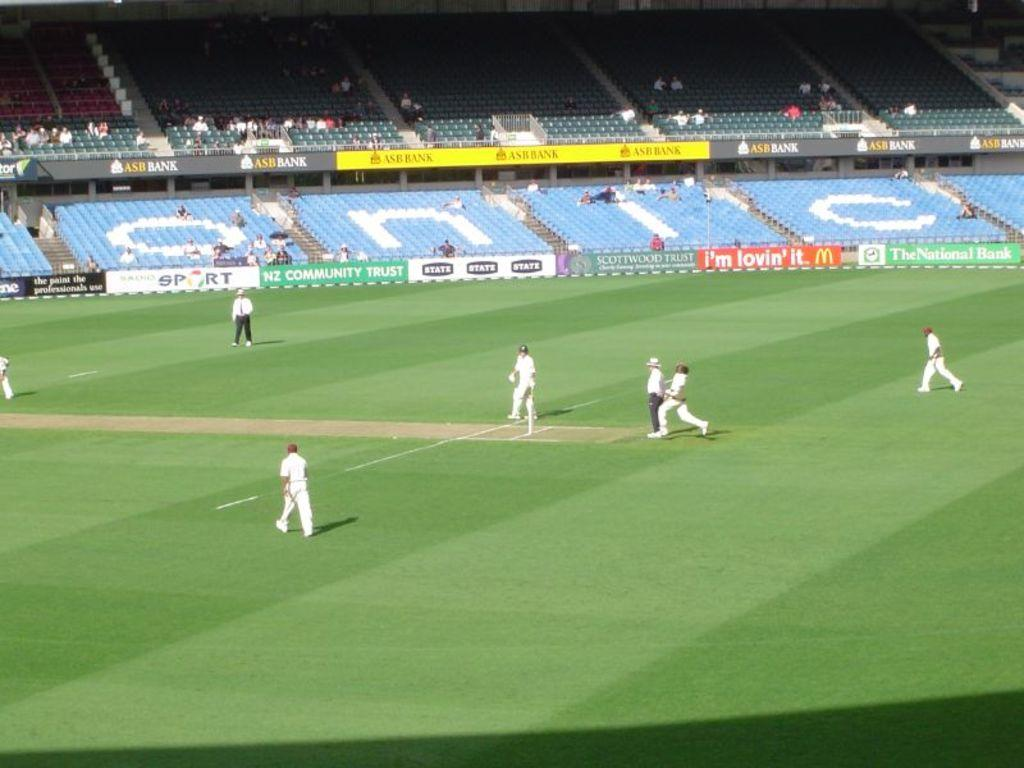<image>
Relay a brief, clear account of the picture shown. McDonalds is one of the sponsors of a sports team currently onfield in front of a few people. 